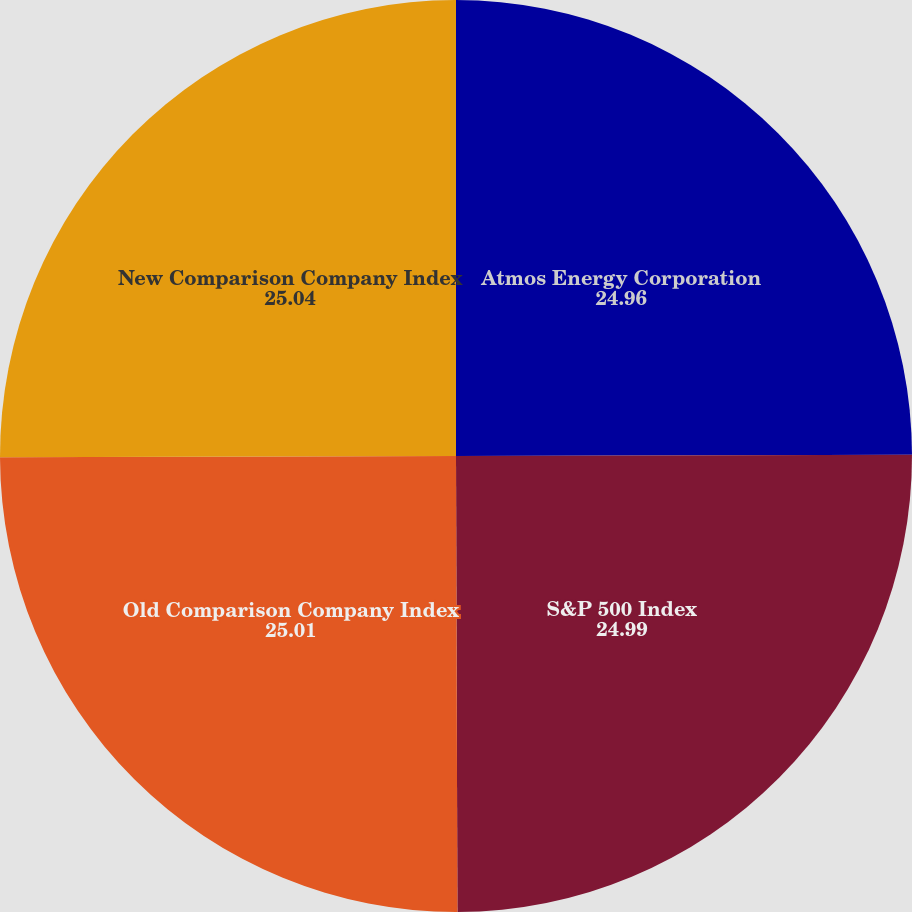Convert chart to OTSL. <chart><loc_0><loc_0><loc_500><loc_500><pie_chart><fcel>Atmos Energy Corporation<fcel>S&P 500 Index<fcel>Old Comparison Company Index<fcel>New Comparison Company Index<nl><fcel>24.96%<fcel>24.99%<fcel>25.01%<fcel>25.04%<nl></chart> 